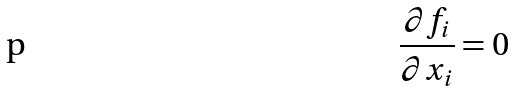<formula> <loc_0><loc_0><loc_500><loc_500>\frac { \partial f _ { i } } { \partial x _ { i } } = 0</formula> 